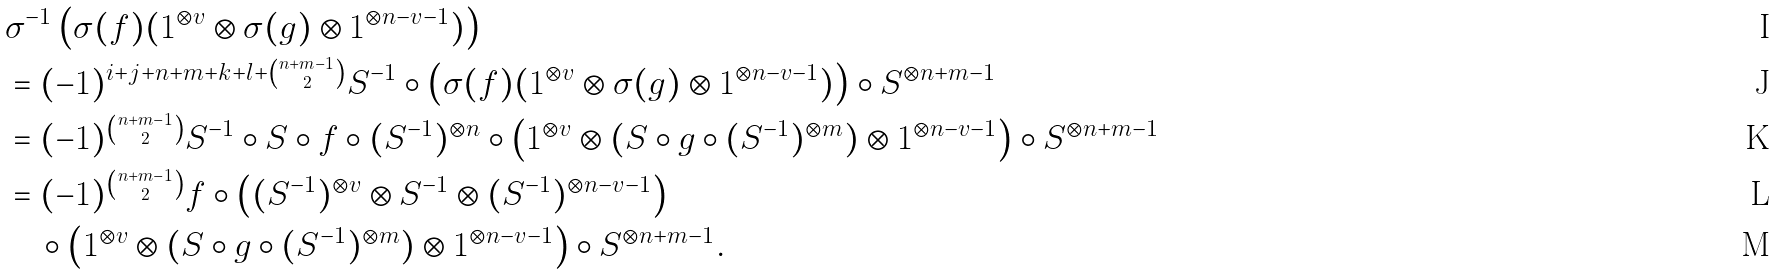<formula> <loc_0><loc_0><loc_500><loc_500>& \sigma ^ { - 1 } \left ( \sigma ( f ) ( 1 ^ { \otimes v } \otimes \sigma ( g ) \otimes 1 ^ { \otimes n - v - 1 } ) \right ) \\ & = ( - 1 ) ^ { i + j + n + m + k + l + \binom { n + m - 1 } { 2 } } S ^ { - 1 } \circ \left ( \sigma ( f ) ( 1 ^ { \otimes v } \otimes \sigma ( g ) \otimes 1 ^ { \otimes n - v - 1 } ) \right ) \circ S ^ { \otimes n + m - 1 } \\ & = ( - 1 ) ^ { \binom { n + m - 1 } { 2 } } S ^ { - 1 } \circ S \circ f \circ ( S ^ { - 1 } ) ^ { \otimes n } \circ \left ( 1 ^ { \otimes v } \otimes ( S \circ g \circ ( S ^ { - 1 } ) ^ { \otimes m } ) \otimes 1 ^ { \otimes n - v - 1 } \right ) \circ S ^ { \otimes n + m - 1 } \\ & = ( - 1 ) ^ { \binom { n + m - 1 } { 2 } } f \circ \left ( ( S ^ { - 1 } ) ^ { \otimes v } \otimes S ^ { - 1 } \otimes ( S ^ { - 1 } ) ^ { \otimes n - v - 1 } \right ) \\ & \quad \circ \left ( 1 ^ { \otimes v } \otimes ( S \circ g \circ ( S ^ { - 1 } ) ^ { \otimes m } ) \otimes 1 ^ { \otimes n - v - 1 } \right ) \circ S ^ { \otimes n + m - 1 } .</formula> 